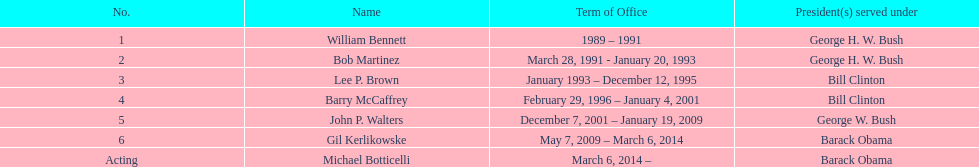Who was the director appointed following lee p. brown? Barry McCaffrey. 